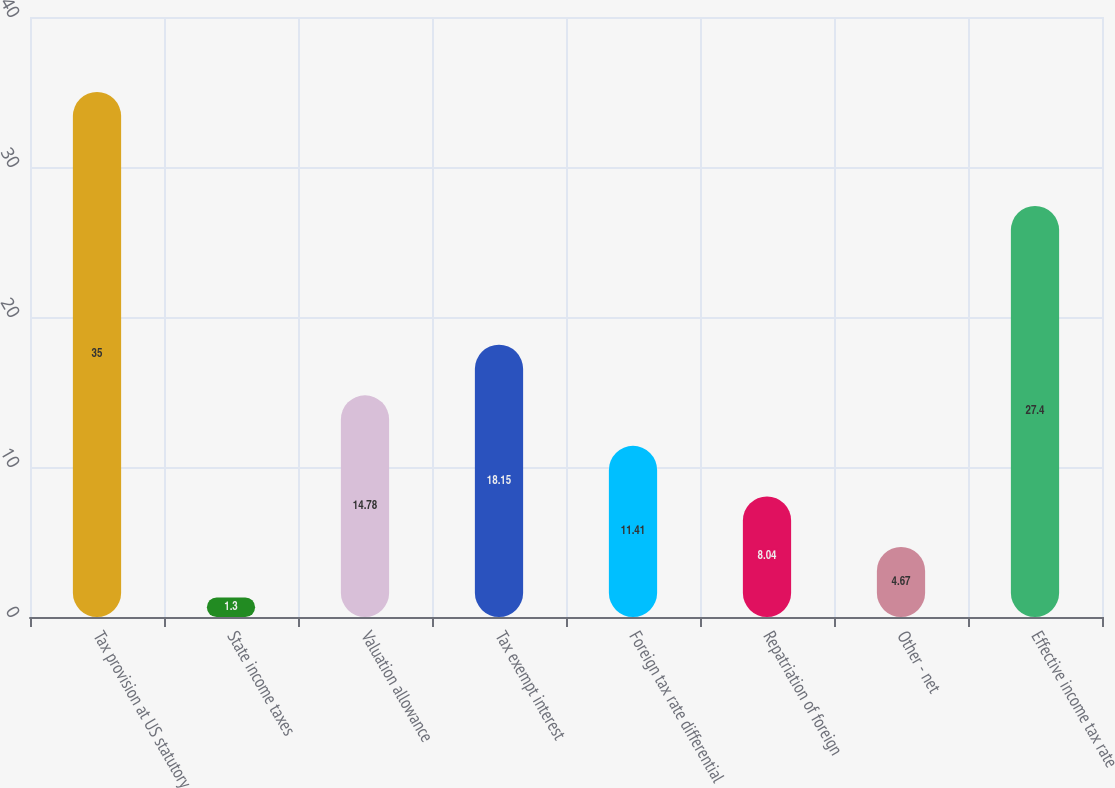<chart> <loc_0><loc_0><loc_500><loc_500><bar_chart><fcel>Tax provision at US statutory<fcel>State income taxes<fcel>Valuation allowance<fcel>Tax exempt interest<fcel>Foreign tax rate differential<fcel>Repatriation of foreign<fcel>Other - net<fcel>Effective income tax rate<nl><fcel>35<fcel>1.3<fcel>14.78<fcel>18.15<fcel>11.41<fcel>8.04<fcel>4.67<fcel>27.4<nl></chart> 